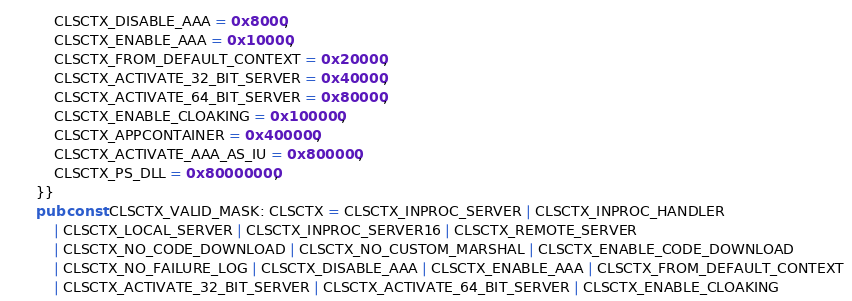Convert code to text. <code><loc_0><loc_0><loc_500><loc_500><_Rust_>    CLSCTX_DISABLE_AAA = 0x8000,
    CLSCTX_ENABLE_AAA = 0x10000,
    CLSCTX_FROM_DEFAULT_CONTEXT = 0x20000,
    CLSCTX_ACTIVATE_32_BIT_SERVER = 0x40000,
    CLSCTX_ACTIVATE_64_BIT_SERVER = 0x80000,
    CLSCTX_ENABLE_CLOAKING = 0x100000,
    CLSCTX_APPCONTAINER = 0x400000,
    CLSCTX_ACTIVATE_AAA_AS_IU = 0x800000,
    CLSCTX_PS_DLL = 0x80000000,
}}
pub const CLSCTX_VALID_MASK: CLSCTX = CLSCTX_INPROC_SERVER | CLSCTX_INPROC_HANDLER
    | CLSCTX_LOCAL_SERVER | CLSCTX_INPROC_SERVER16 | CLSCTX_REMOTE_SERVER
    | CLSCTX_NO_CODE_DOWNLOAD | CLSCTX_NO_CUSTOM_MARSHAL | CLSCTX_ENABLE_CODE_DOWNLOAD
    | CLSCTX_NO_FAILURE_LOG | CLSCTX_DISABLE_AAA | CLSCTX_ENABLE_AAA | CLSCTX_FROM_DEFAULT_CONTEXT
    | CLSCTX_ACTIVATE_32_BIT_SERVER | CLSCTX_ACTIVATE_64_BIT_SERVER | CLSCTX_ENABLE_CLOAKING</code> 